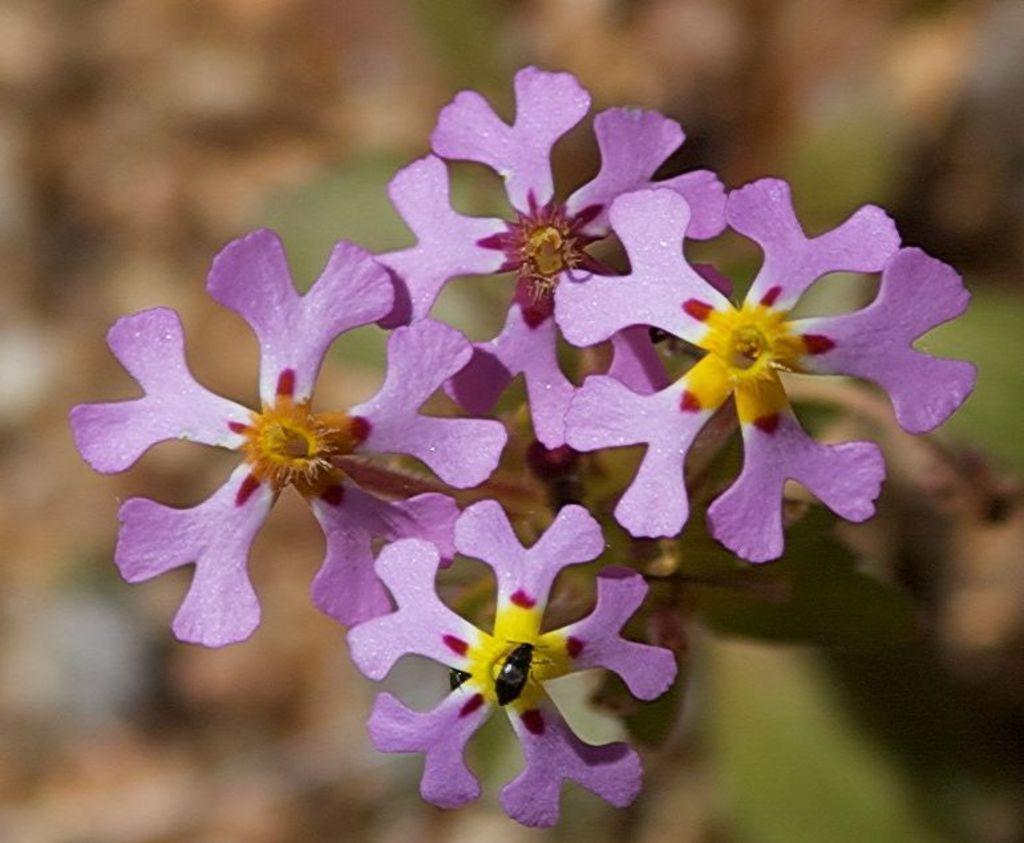Please provide a concise description of this image. In this image I can see an insect on the flower and the flowers are in purple and yellow color and I can see the blurred background. 